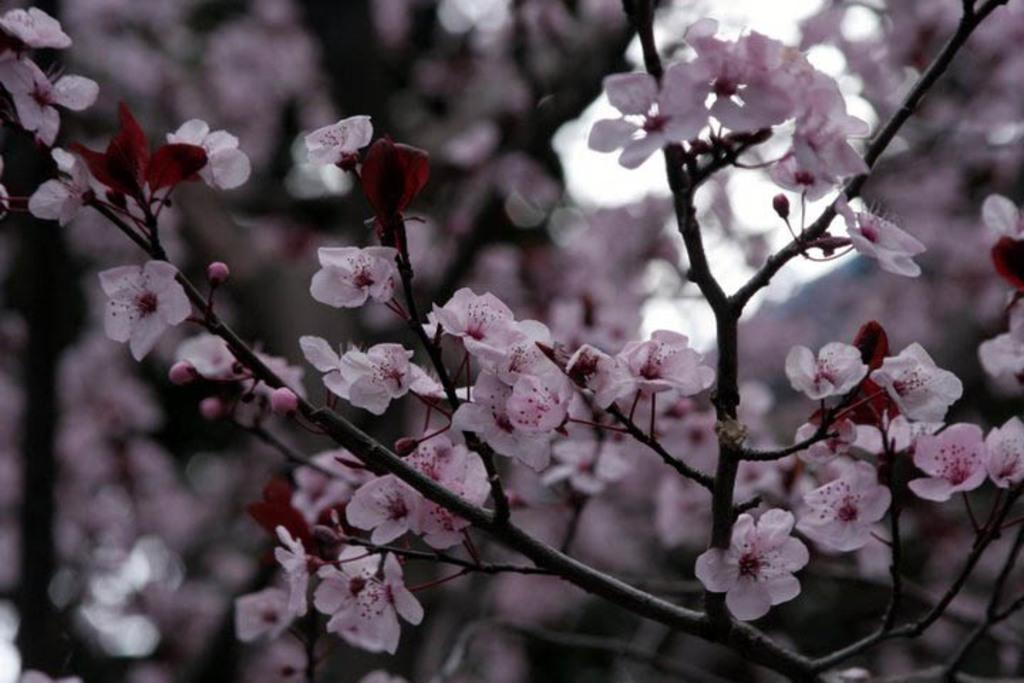What is the main subject of the image? The main subject of the image is a tree. What can be observed about the tree in the image? The tree has flowers and buds. How would you describe the background of the image? The background of the image is blurred. What type of popcorn is being used for learning during the vacation in the image? There is no popcorn, vacation, or learning activity present in the image; it features a tree with flowers and buds. 